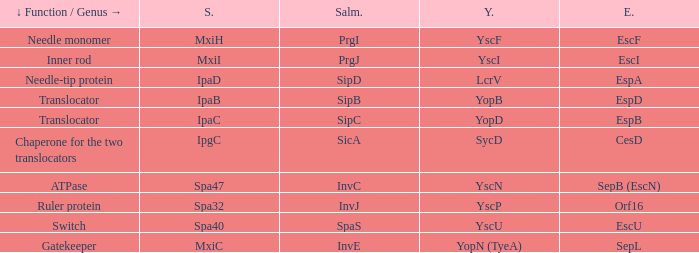Tell me the shigella for yersinia yopb IpaB. Could you parse the entire table? {'header': ['↓ Function / Genus →', 'S.', 'Salm.', 'Y.', 'E.'], 'rows': [['Needle monomer', 'MxiH', 'PrgI', 'YscF', 'EscF'], ['Inner rod', 'MxiI', 'PrgJ', 'YscI', 'EscI'], ['Needle-tip protein', 'IpaD', 'SipD', 'LcrV', 'EspA'], ['Translocator', 'IpaB', 'SipB', 'YopB', 'EspD'], ['Translocator', 'IpaC', 'SipC', 'YopD', 'EspB'], ['Chaperone for the two translocators', 'IpgC', 'SicA', 'SycD', 'CesD'], ['ATPase', 'Spa47', 'InvC', 'YscN', 'SepB (EscN)'], ['Ruler protein', 'Spa32', 'InvJ', 'YscP', 'Orf16'], ['Switch', 'Spa40', 'SpaS', 'YscU', 'EscU'], ['Gatekeeper', 'MxiC', 'InvE', 'YopN (TyeA)', 'SepL']]} 